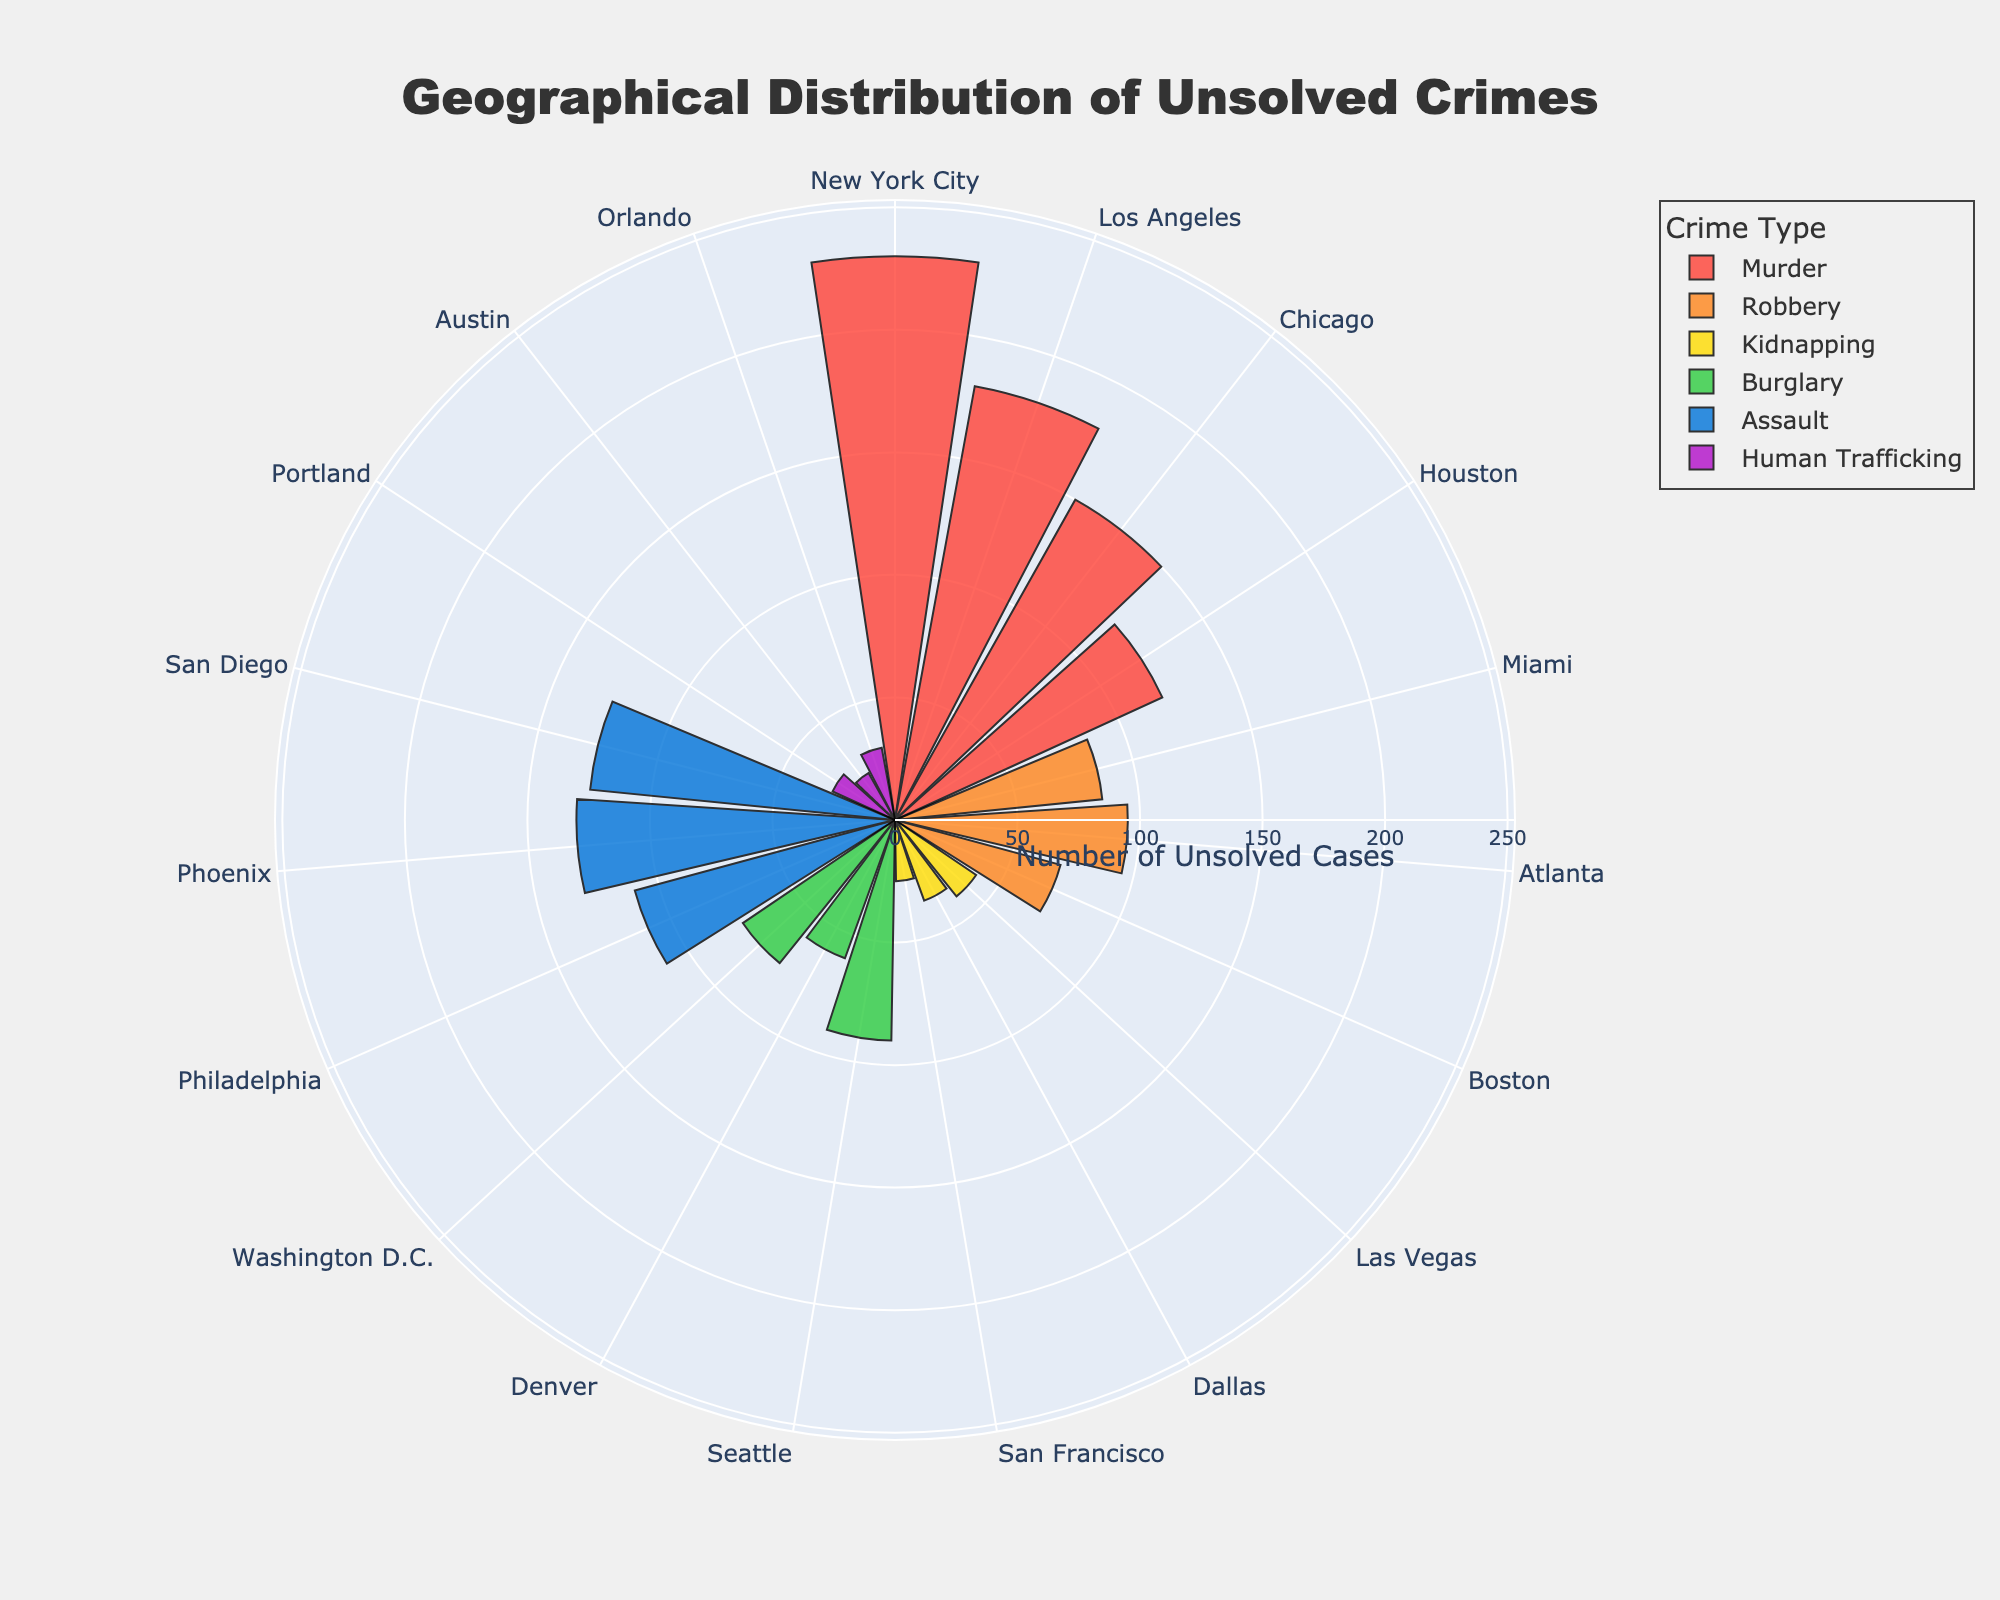What is the title of the figure? The title is located at the top of the figure and usually describes the main topic represented by the chart.
Answer: Geographical Distribution of Unsolved Crimes Which type of crime has the most unsolved cases in New York City? By looking at the bars corresponding to New York City and comparing their lengths, the bar for Murder is the longest.
Answer: Murder What is the total number of unsolved Murder cases in the figure? Add the numbers of unsolved Murder cases from all locations: 230 (New York City) + 180 (Los Angeles) + 150 (Chicago) + 120 (Houston).
Answer: 680 Which city has the least number of unsolved Kidnapping cases? Compare the lengths of the bars for Kidnapping in Las Vegas, Dallas, and San Francisco. The shortest bar corresponds to San Francisco.
Answer: San Francisco How do the unsolved Robbery cases in Miami compare to those in Atlanta? By examining the length of the Robbery bars, Miami has 85 unsolved cases and Atlanta has 95. Therefore, Miami has fewer unsolved cases.
Answer: Miami has fewer unsolved cases Which type of crime appears to be most prevalent in Houston? Look at all bars corresponding to Houston and determine which one is the longest – for Murder.
Answer: Murder What is the average number of unsolved Burglary cases across Seattle, Denver, and Washington D.C.? Sum the unsolved Burglary cases in Seattle (90), Denver (60), and Washington D.C. (75), and then divide by three. Calculation: (90 + 60 + 75) / 3 = 75.
Answer: 75 Is there any crime type for which all recorded locations have fewer than 50 unsolved cases? Look at the counts for each type. For Kidnapping, the highest value is 40 in Las Vegas, which is below 50.
Answer: Kidnapping Which type of crime has the highest number of unsolved cases in Phoenix? The tallest bar corresponding to Phoenix represents Assault with 130 unsolved cases.
Answer: Assault How does the number of unsolved Human Trafficking cases in Orlando compare with those in Austin? By examining the bars for Human Trafficking, Orlando has 30 cases and Austin has 22. Therefore, Orlando has more unsolved cases.
Answer: Orlando has more unsolved cases 